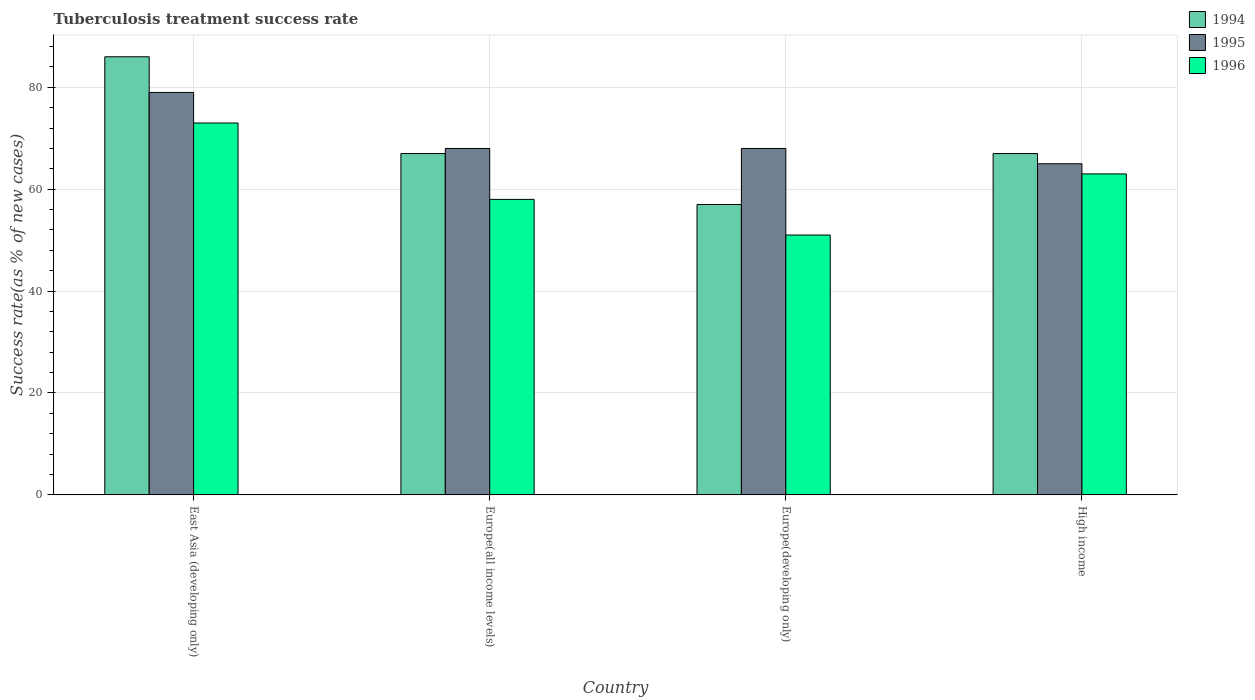Are the number of bars per tick equal to the number of legend labels?
Provide a succinct answer. Yes. What is the label of the 1st group of bars from the left?
Keep it short and to the point. East Asia (developing only). What is the tuberculosis treatment success rate in 1995 in East Asia (developing only)?
Give a very brief answer. 79. Across all countries, what is the maximum tuberculosis treatment success rate in 1994?
Ensure brevity in your answer.  86. In which country was the tuberculosis treatment success rate in 1994 maximum?
Provide a succinct answer. East Asia (developing only). What is the total tuberculosis treatment success rate in 1994 in the graph?
Provide a short and direct response. 277. What is the difference between the tuberculosis treatment success rate in 1996 in Europe(developing only) and the tuberculosis treatment success rate in 1995 in Europe(all income levels)?
Make the answer very short. -17. What is the average tuberculosis treatment success rate in 1996 per country?
Your answer should be very brief. 61.25. In how many countries, is the tuberculosis treatment success rate in 1995 greater than 44 %?
Your answer should be compact. 4. What is the ratio of the tuberculosis treatment success rate in 1995 in Europe(all income levels) to that in High income?
Your answer should be very brief. 1.05. Is the difference between the tuberculosis treatment success rate in 1995 in Europe(developing only) and High income greater than the difference between the tuberculosis treatment success rate in 1996 in Europe(developing only) and High income?
Your answer should be very brief. Yes. What is the difference between the highest and the lowest tuberculosis treatment success rate in 1996?
Offer a very short reply. 22. Is the sum of the tuberculosis treatment success rate in 1996 in Europe(developing only) and High income greater than the maximum tuberculosis treatment success rate in 1994 across all countries?
Give a very brief answer. Yes. What does the 1st bar from the left in Europe(developing only) represents?
Your answer should be very brief. 1994. What does the 3rd bar from the right in Europe(all income levels) represents?
Your answer should be compact. 1994. How many countries are there in the graph?
Ensure brevity in your answer.  4. What is the difference between two consecutive major ticks on the Y-axis?
Offer a very short reply. 20. Are the values on the major ticks of Y-axis written in scientific E-notation?
Offer a very short reply. No. Does the graph contain grids?
Your response must be concise. Yes. What is the title of the graph?
Make the answer very short. Tuberculosis treatment success rate. What is the label or title of the X-axis?
Provide a short and direct response. Country. What is the label or title of the Y-axis?
Keep it short and to the point. Success rate(as % of new cases). What is the Success rate(as % of new cases) of 1995 in East Asia (developing only)?
Ensure brevity in your answer.  79. What is the Success rate(as % of new cases) of 1994 in Europe(all income levels)?
Keep it short and to the point. 67. What is the Success rate(as % of new cases) in 1994 in Europe(developing only)?
Your answer should be compact. 57. What is the Success rate(as % of new cases) in 1996 in Europe(developing only)?
Give a very brief answer. 51. What is the Success rate(as % of new cases) in 1994 in High income?
Offer a terse response. 67. Across all countries, what is the maximum Success rate(as % of new cases) in 1994?
Provide a short and direct response. 86. Across all countries, what is the maximum Success rate(as % of new cases) of 1995?
Keep it short and to the point. 79. Across all countries, what is the maximum Success rate(as % of new cases) of 1996?
Offer a very short reply. 73. Across all countries, what is the minimum Success rate(as % of new cases) of 1994?
Make the answer very short. 57. Across all countries, what is the minimum Success rate(as % of new cases) of 1995?
Your response must be concise. 65. Across all countries, what is the minimum Success rate(as % of new cases) of 1996?
Give a very brief answer. 51. What is the total Success rate(as % of new cases) in 1994 in the graph?
Offer a very short reply. 277. What is the total Success rate(as % of new cases) of 1995 in the graph?
Offer a very short reply. 280. What is the total Success rate(as % of new cases) in 1996 in the graph?
Your answer should be very brief. 245. What is the difference between the Success rate(as % of new cases) in 1996 in East Asia (developing only) and that in Europe(all income levels)?
Give a very brief answer. 15. What is the difference between the Success rate(as % of new cases) of 1995 in East Asia (developing only) and that in Europe(developing only)?
Offer a terse response. 11. What is the difference between the Success rate(as % of new cases) in 1994 in East Asia (developing only) and that in High income?
Your response must be concise. 19. What is the difference between the Success rate(as % of new cases) of 1995 in East Asia (developing only) and that in High income?
Provide a short and direct response. 14. What is the difference between the Success rate(as % of new cases) of 1994 in Europe(all income levels) and that in Europe(developing only)?
Offer a very short reply. 10. What is the difference between the Success rate(as % of new cases) in 1994 in Europe(all income levels) and that in High income?
Your answer should be compact. 0. What is the difference between the Success rate(as % of new cases) in 1995 in Europe(all income levels) and that in High income?
Provide a short and direct response. 3. What is the difference between the Success rate(as % of new cases) of 1996 in Europe(all income levels) and that in High income?
Your answer should be very brief. -5. What is the difference between the Success rate(as % of new cases) of 1994 in Europe(developing only) and that in High income?
Your answer should be very brief. -10. What is the difference between the Success rate(as % of new cases) of 1996 in Europe(developing only) and that in High income?
Your answer should be very brief. -12. What is the difference between the Success rate(as % of new cases) in 1994 in East Asia (developing only) and the Success rate(as % of new cases) in 1995 in Europe(all income levels)?
Ensure brevity in your answer.  18. What is the difference between the Success rate(as % of new cases) of 1994 in East Asia (developing only) and the Success rate(as % of new cases) of 1995 in Europe(developing only)?
Keep it short and to the point. 18. What is the difference between the Success rate(as % of new cases) in 1994 in East Asia (developing only) and the Success rate(as % of new cases) in 1996 in High income?
Ensure brevity in your answer.  23. What is the difference between the Success rate(as % of new cases) of 1994 in Europe(all income levels) and the Success rate(as % of new cases) of 1996 in Europe(developing only)?
Make the answer very short. 16. What is the difference between the Success rate(as % of new cases) of 1995 in Europe(all income levels) and the Success rate(as % of new cases) of 1996 in Europe(developing only)?
Keep it short and to the point. 17. What is the difference between the Success rate(as % of new cases) in 1994 in Europe(all income levels) and the Success rate(as % of new cases) in 1996 in High income?
Give a very brief answer. 4. What is the average Success rate(as % of new cases) in 1994 per country?
Keep it short and to the point. 69.25. What is the average Success rate(as % of new cases) in 1996 per country?
Your answer should be very brief. 61.25. What is the difference between the Success rate(as % of new cases) in 1995 and Success rate(as % of new cases) in 1996 in East Asia (developing only)?
Your answer should be very brief. 6. What is the difference between the Success rate(as % of new cases) of 1994 and Success rate(as % of new cases) of 1995 in Europe(all income levels)?
Provide a succinct answer. -1. What is the difference between the Success rate(as % of new cases) in 1994 and Success rate(as % of new cases) in 1995 in Europe(developing only)?
Your answer should be compact. -11. What is the difference between the Success rate(as % of new cases) in 1994 and Success rate(as % of new cases) in 1996 in Europe(developing only)?
Provide a succinct answer. 6. What is the difference between the Success rate(as % of new cases) in 1994 and Success rate(as % of new cases) in 1996 in High income?
Ensure brevity in your answer.  4. What is the ratio of the Success rate(as % of new cases) of 1994 in East Asia (developing only) to that in Europe(all income levels)?
Offer a terse response. 1.28. What is the ratio of the Success rate(as % of new cases) in 1995 in East Asia (developing only) to that in Europe(all income levels)?
Make the answer very short. 1.16. What is the ratio of the Success rate(as % of new cases) in 1996 in East Asia (developing only) to that in Europe(all income levels)?
Offer a very short reply. 1.26. What is the ratio of the Success rate(as % of new cases) in 1994 in East Asia (developing only) to that in Europe(developing only)?
Provide a succinct answer. 1.51. What is the ratio of the Success rate(as % of new cases) of 1995 in East Asia (developing only) to that in Europe(developing only)?
Your answer should be very brief. 1.16. What is the ratio of the Success rate(as % of new cases) in 1996 in East Asia (developing only) to that in Europe(developing only)?
Your answer should be compact. 1.43. What is the ratio of the Success rate(as % of new cases) in 1994 in East Asia (developing only) to that in High income?
Provide a succinct answer. 1.28. What is the ratio of the Success rate(as % of new cases) of 1995 in East Asia (developing only) to that in High income?
Keep it short and to the point. 1.22. What is the ratio of the Success rate(as % of new cases) of 1996 in East Asia (developing only) to that in High income?
Offer a terse response. 1.16. What is the ratio of the Success rate(as % of new cases) in 1994 in Europe(all income levels) to that in Europe(developing only)?
Your answer should be compact. 1.18. What is the ratio of the Success rate(as % of new cases) in 1996 in Europe(all income levels) to that in Europe(developing only)?
Provide a short and direct response. 1.14. What is the ratio of the Success rate(as % of new cases) in 1995 in Europe(all income levels) to that in High income?
Ensure brevity in your answer.  1.05. What is the ratio of the Success rate(as % of new cases) in 1996 in Europe(all income levels) to that in High income?
Your answer should be compact. 0.92. What is the ratio of the Success rate(as % of new cases) of 1994 in Europe(developing only) to that in High income?
Your response must be concise. 0.85. What is the ratio of the Success rate(as % of new cases) in 1995 in Europe(developing only) to that in High income?
Offer a very short reply. 1.05. What is the ratio of the Success rate(as % of new cases) of 1996 in Europe(developing only) to that in High income?
Provide a succinct answer. 0.81. What is the difference between the highest and the second highest Success rate(as % of new cases) of 1994?
Provide a short and direct response. 19. What is the difference between the highest and the second highest Success rate(as % of new cases) of 1995?
Your answer should be very brief. 11. What is the difference between the highest and the lowest Success rate(as % of new cases) of 1994?
Offer a terse response. 29. What is the difference between the highest and the lowest Success rate(as % of new cases) in 1996?
Offer a very short reply. 22. 